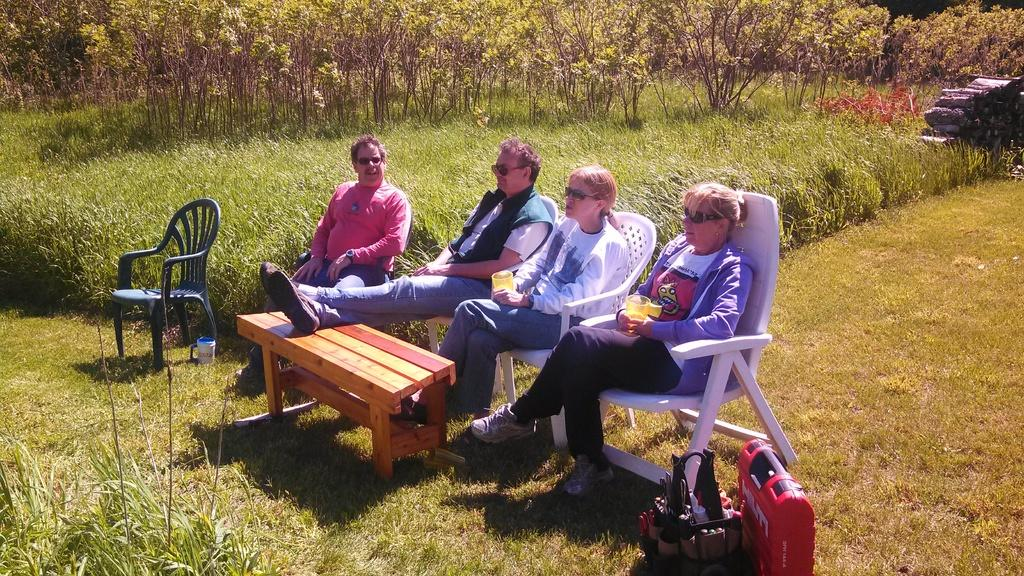How many people are sitting in the image? There are four people sitting on chairs in the image. What can be seen on the table in the image? There is a cup and a jug on the table in the image. What is present near the table in the image? There is a bag in the image. What type of natural environment is visible in the image? There are trees, logs, and grass in the image. What song is being sung by the people in the image? There is no indication in the image that the people are singing a song. What type of folding tool is present in the image? There are no folding tools, such as scissors, present in the image. 